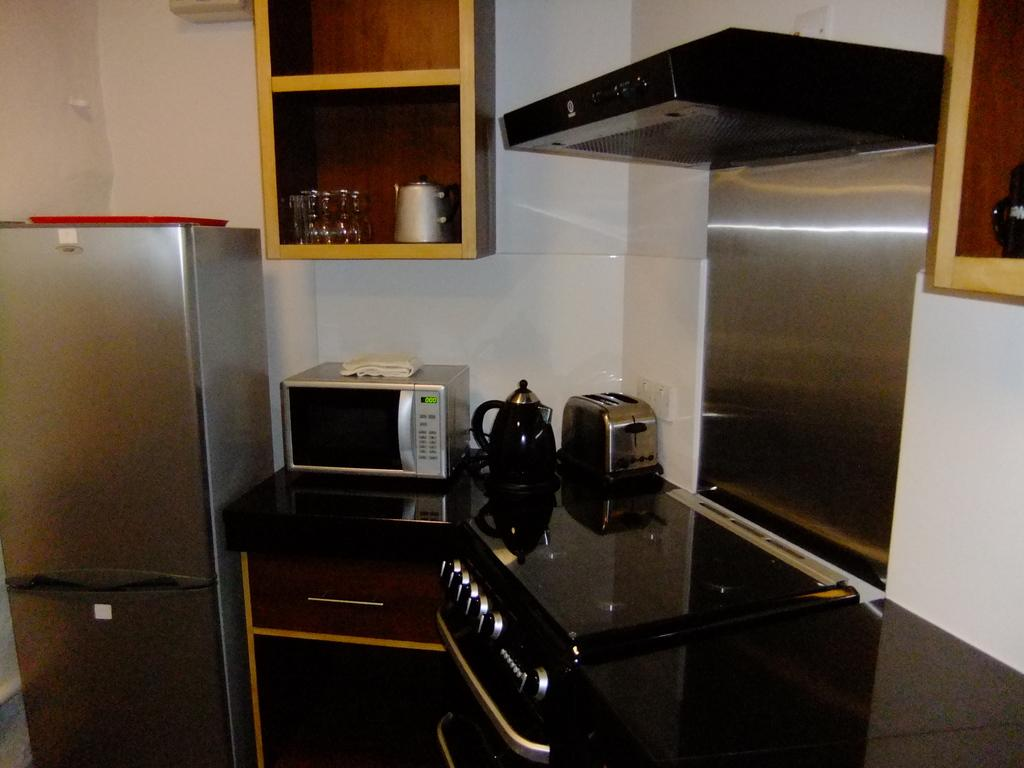What type of objects can be seen in the image? There are kettles, a wall, a refrigerator, glass objects, and shelves in the image. Can you describe the wall in the image? There is a wall in the image, but no specific details about its appearance are provided. What is the purpose of the shelves in the image? The shelves are likely used for storage or displaying objects, but their specific purpose cannot be determined from the facts. What is the object on the right side top of the image? The facts do not specify the object on the right side top of the image, so we cannot answer this question. Where are the children playing in the image? There are no children present in the image, so we cannot answer this question. What type of scale is used to weigh the objects in the image? There is no scale present in the image, so we cannot answer this question. 